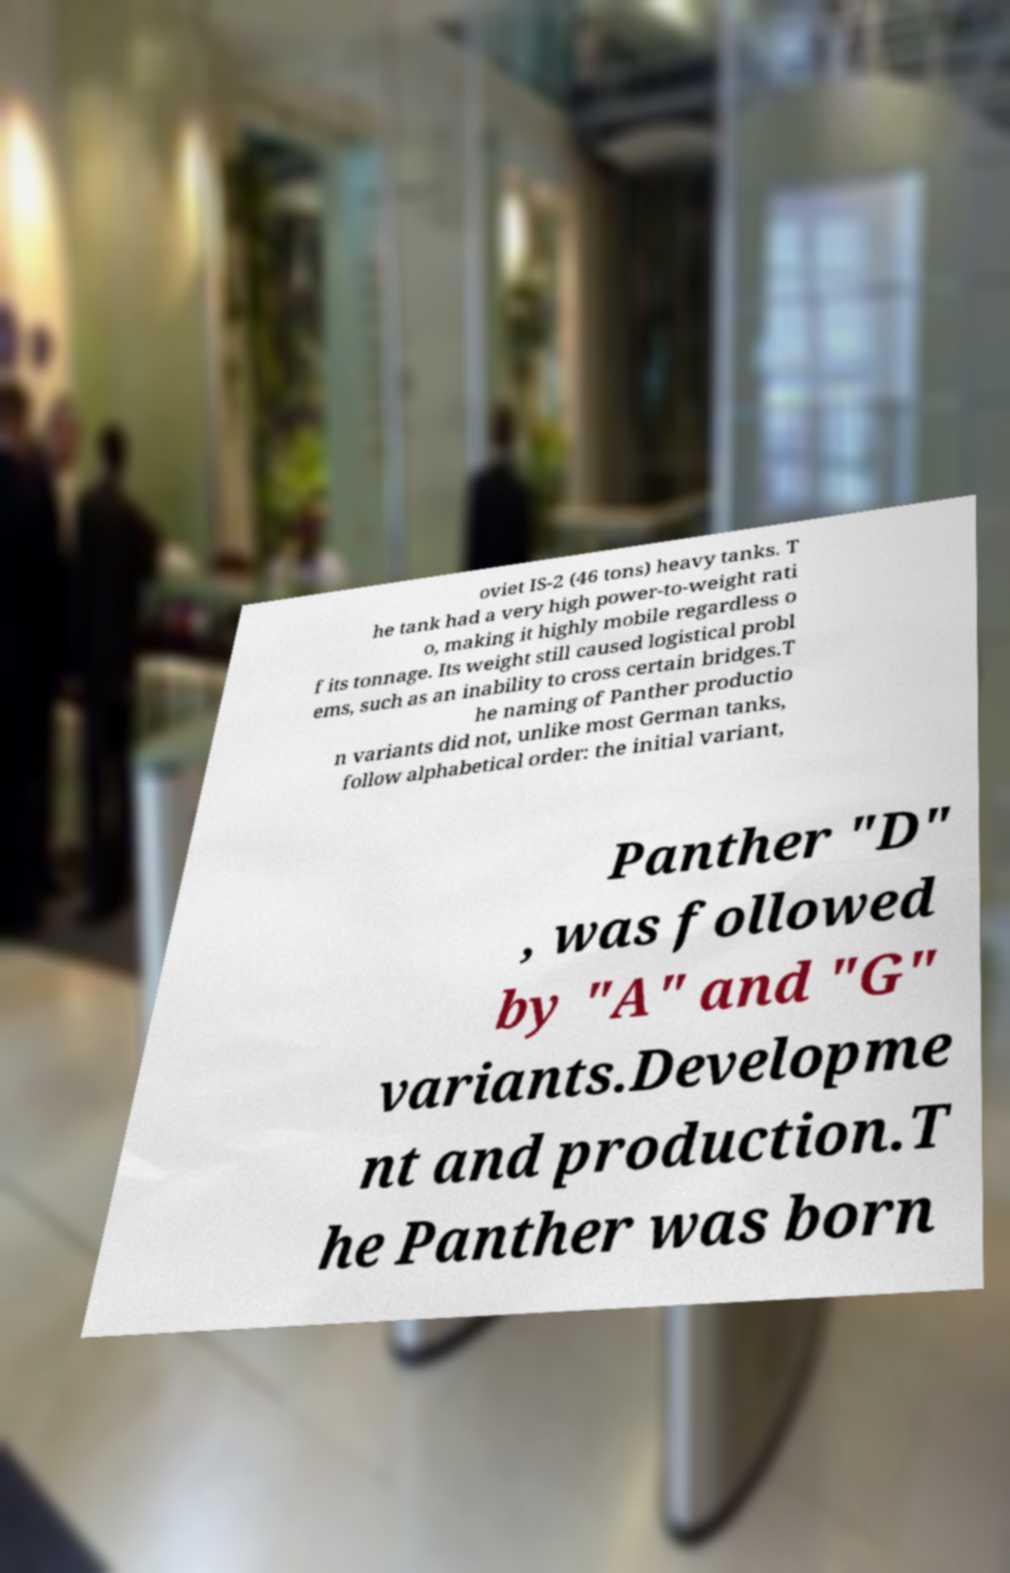Please read and relay the text visible in this image. What does it say? oviet IS-2 (46 tons) heavy tanks. T he tank had a very high power-to-weight rati o, making it highly mobile regardless o f its tonnage. Its weight still caused logistical probl ems, such as an inability to cross certain bridges.T he naming of Panther productio n variants did not, unlike most German tanks, follow alphabetical order: the initial variant, Panther "D" , was followed by "A" and "G" variants.Developme nt and production.T he Panther was born 